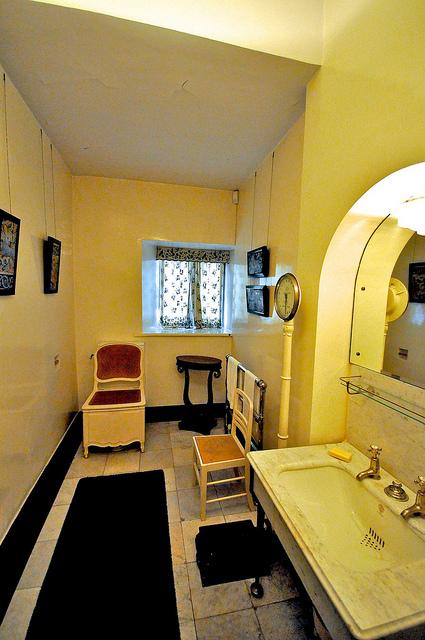Are the curtains open?
Give a very brief answer. No. What is reflected in the mirror?
Concise answer only. Hat. What kind of room is this?
Answer briefly. Bathroom. 